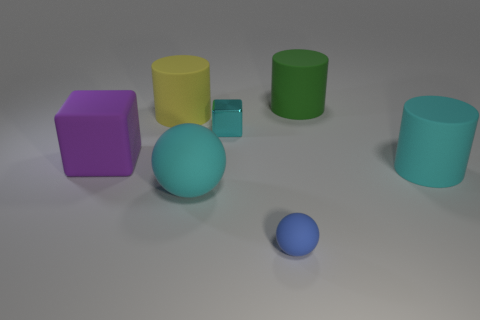Subtract all cyan cylinders. How many cylinders are left? 2 Subtract all cyan cylinders. How many cylinders are left? 2 Subtract all spheres. How many objects are left? 5 Add 3 green things. How many objects exist? 10 Subtract 0 yellow balls. How many objects are left? 7 Subtract all cyan spheres. Subtract all gray cylinders. How many spheres are left? 1 Subtract all blue cylinders. How many yellow blocks are left? 0 Subtract all red matte spheres. Subtract all large green cylinders. How many objects are left? 6 Add 2 purple matte blocks. How many purple matte blocks are left? 3 Add 7 large brown shiny things. How many large brown shiny things exist? 7 